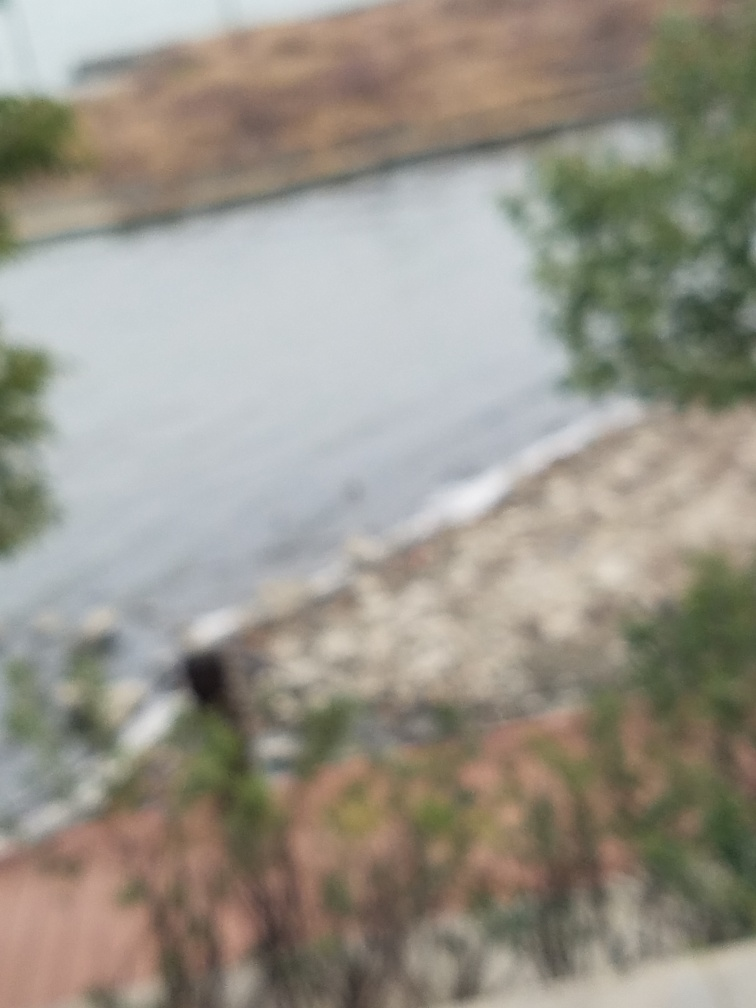Can you tell what time of day it might be in this image? Due to the blurriness of the image, it's challenging to determine the exact time of day. However, the overall lightness suggests it could be daytime. 